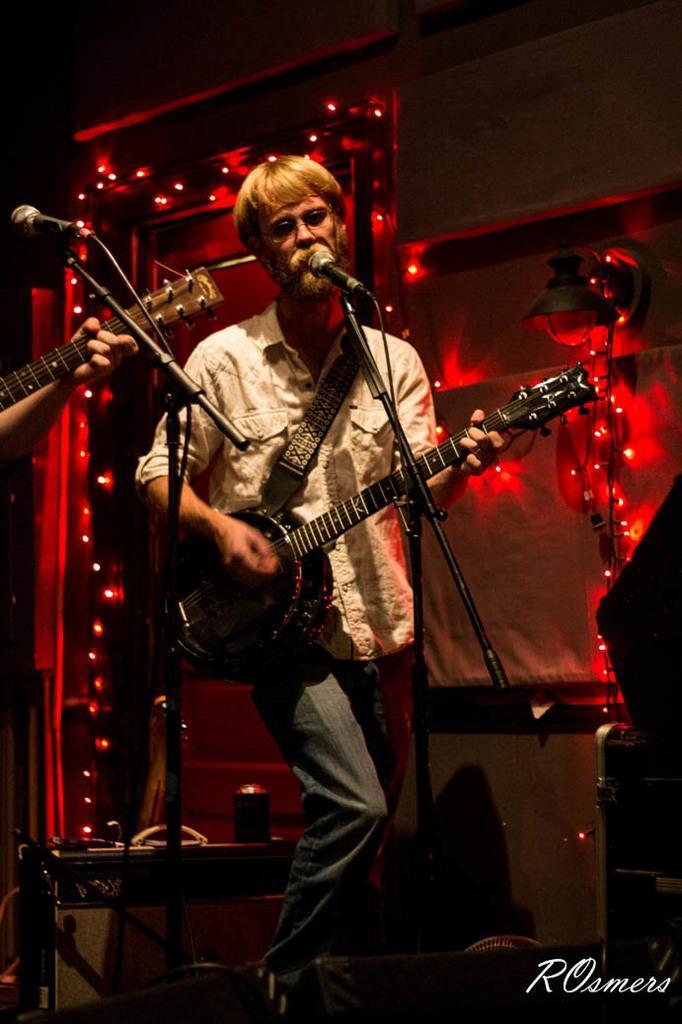How would you summarize this image in a sentence or two? He is standing. He is holding a guitar. He is playing a guitar. He is singing a song. We can see in background lights. 